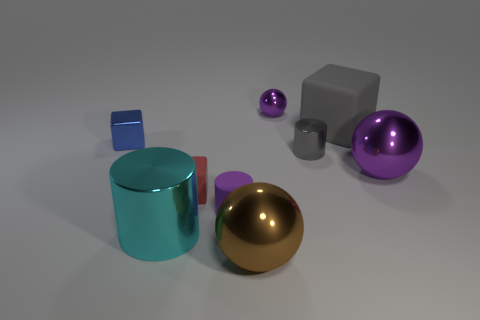Are the red block and the large purple thing made of the same material?
Your response must be concise. No. How many large balls are both behind the large brown shiny thing and to the left of the large matte thing?
Keep it short and to the point. 0. What number of other objects are there of the same color as the matte cylinder?
Ensure brevity in your answer.  2. What number of gray things are rubber balls or small matte things?
Keep it short and to the point. 0. The matte cylinder is what size?
Offer a very short reply. Small. How many matte objects are either tiny red cylinders or brown objects?
Give a very brief answer. 0. Is the number of tiny gray spheres less than the number of small blue metallic cubes?
Provide a short and direct response. Yes. How many other things are there of the same material as the big cylinder?
Offer a terse response. 5. The gray object that is the same shape as the tiny blue shiny thing is what size?
Provide a succinct answer. Large. Is the material of the tiny purple thing behind the small metallic cylinder the same as the cylinder in front of the small purple matte cylinder?
Your response must be concise. Yes. 